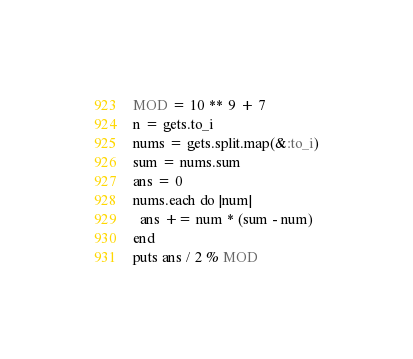Convert code to text. <code><loc_0><loc_0><loc_500><loc_500><_Ruby_>MOD = 10 ** 9 + 7
n = gets.to_i
nums = gets.split.map(&:to_i)
sum = nums.sum
ans = 0
nums.each do |num|
  ans += num * (sum - num)
end
puts ans / 2 % MOD
</code> 